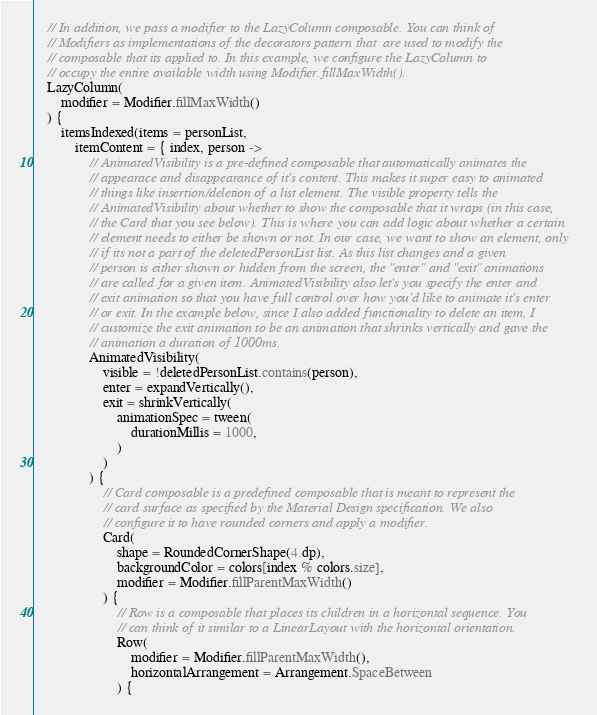Convert code to text. <code><loc_0><loc_0><loc_500><loc_500><_Kotlin_>    // In addition, we pass a modifier to the LazyColumn composable. You can think of
    // Modifiers as implementations of the decorators pattern that  are used to modify the 
    // composable that its applied to. In this example, we configure the LazyColumn to 
    // occupy the entire available width using Modifier.fillMaxWidth().
    LazyColumn(
        modifier = Modifier.fillMaxWidth()
    ) {
        itemsIndexed(items = personList,
            itemContent = { index, person ->
                // AnimatedVisibility is a pre-defined composable that automatically animates the 
                // appearace and disappearance of it's content. This makes it super easy to animated 
                // things like insertion/deletion of a list element. The visible property tells the
                // AnimatedVisibility about whether to show the composable that it wraps (in this case, 
                // the Card that you see below). This is where you can add logic about whether a certain 
                // element needs to either be shown or not. In our case, we want to show an element, only
                // if its not a part of the deletedPersonList list. As this list changes and a given 
                // person is either shown or hidden from the screen, the "enter" and "exit" animations 
                // are called for a given item. AnimatedVisibility also let's you specify the enter and 
                // exit animation so that you have full control over how you'd like to animate it's enter
                // or exit. In the example below, since I also added functionality to delete an item, I 
                // customize the exit animation to be an animation that shrinks vertically and gave the 
                // animation a duration of 1000ms. 
                AnimatedVisibility(
                    visible = !deletedPersonList.contains(person),
                    enter = expandVertically(),
                    exit = shrinkVertically(
                        animationSpec = tween(
                            durationMillis = 1000,
                        )
                    )
                ) {
                    // Card composable is a predefined composable that is meant to represent the 
                    // card surface as specified by the Material Design specification. We also 
                    // configure it to have rounded corners and apply a modifier.
                    Card(
                        shape = RoundedCornerShape(4.dp),
                        backgroundColor = colors[index % colors.size],
                        modifier = Modifier.fillParentMaxWidth()
                    ) {
                        // Row is a composable that places its children in a horizontal sequence. You
                        // can think of it similar to a LinearLayout with the horizontal orientation.
                        Row(
                            modifier = Modifier.fillParentMaxWidth(),
                            horizontalArrangement = Arrangement.SpaceBetween
                        ) {</code> 